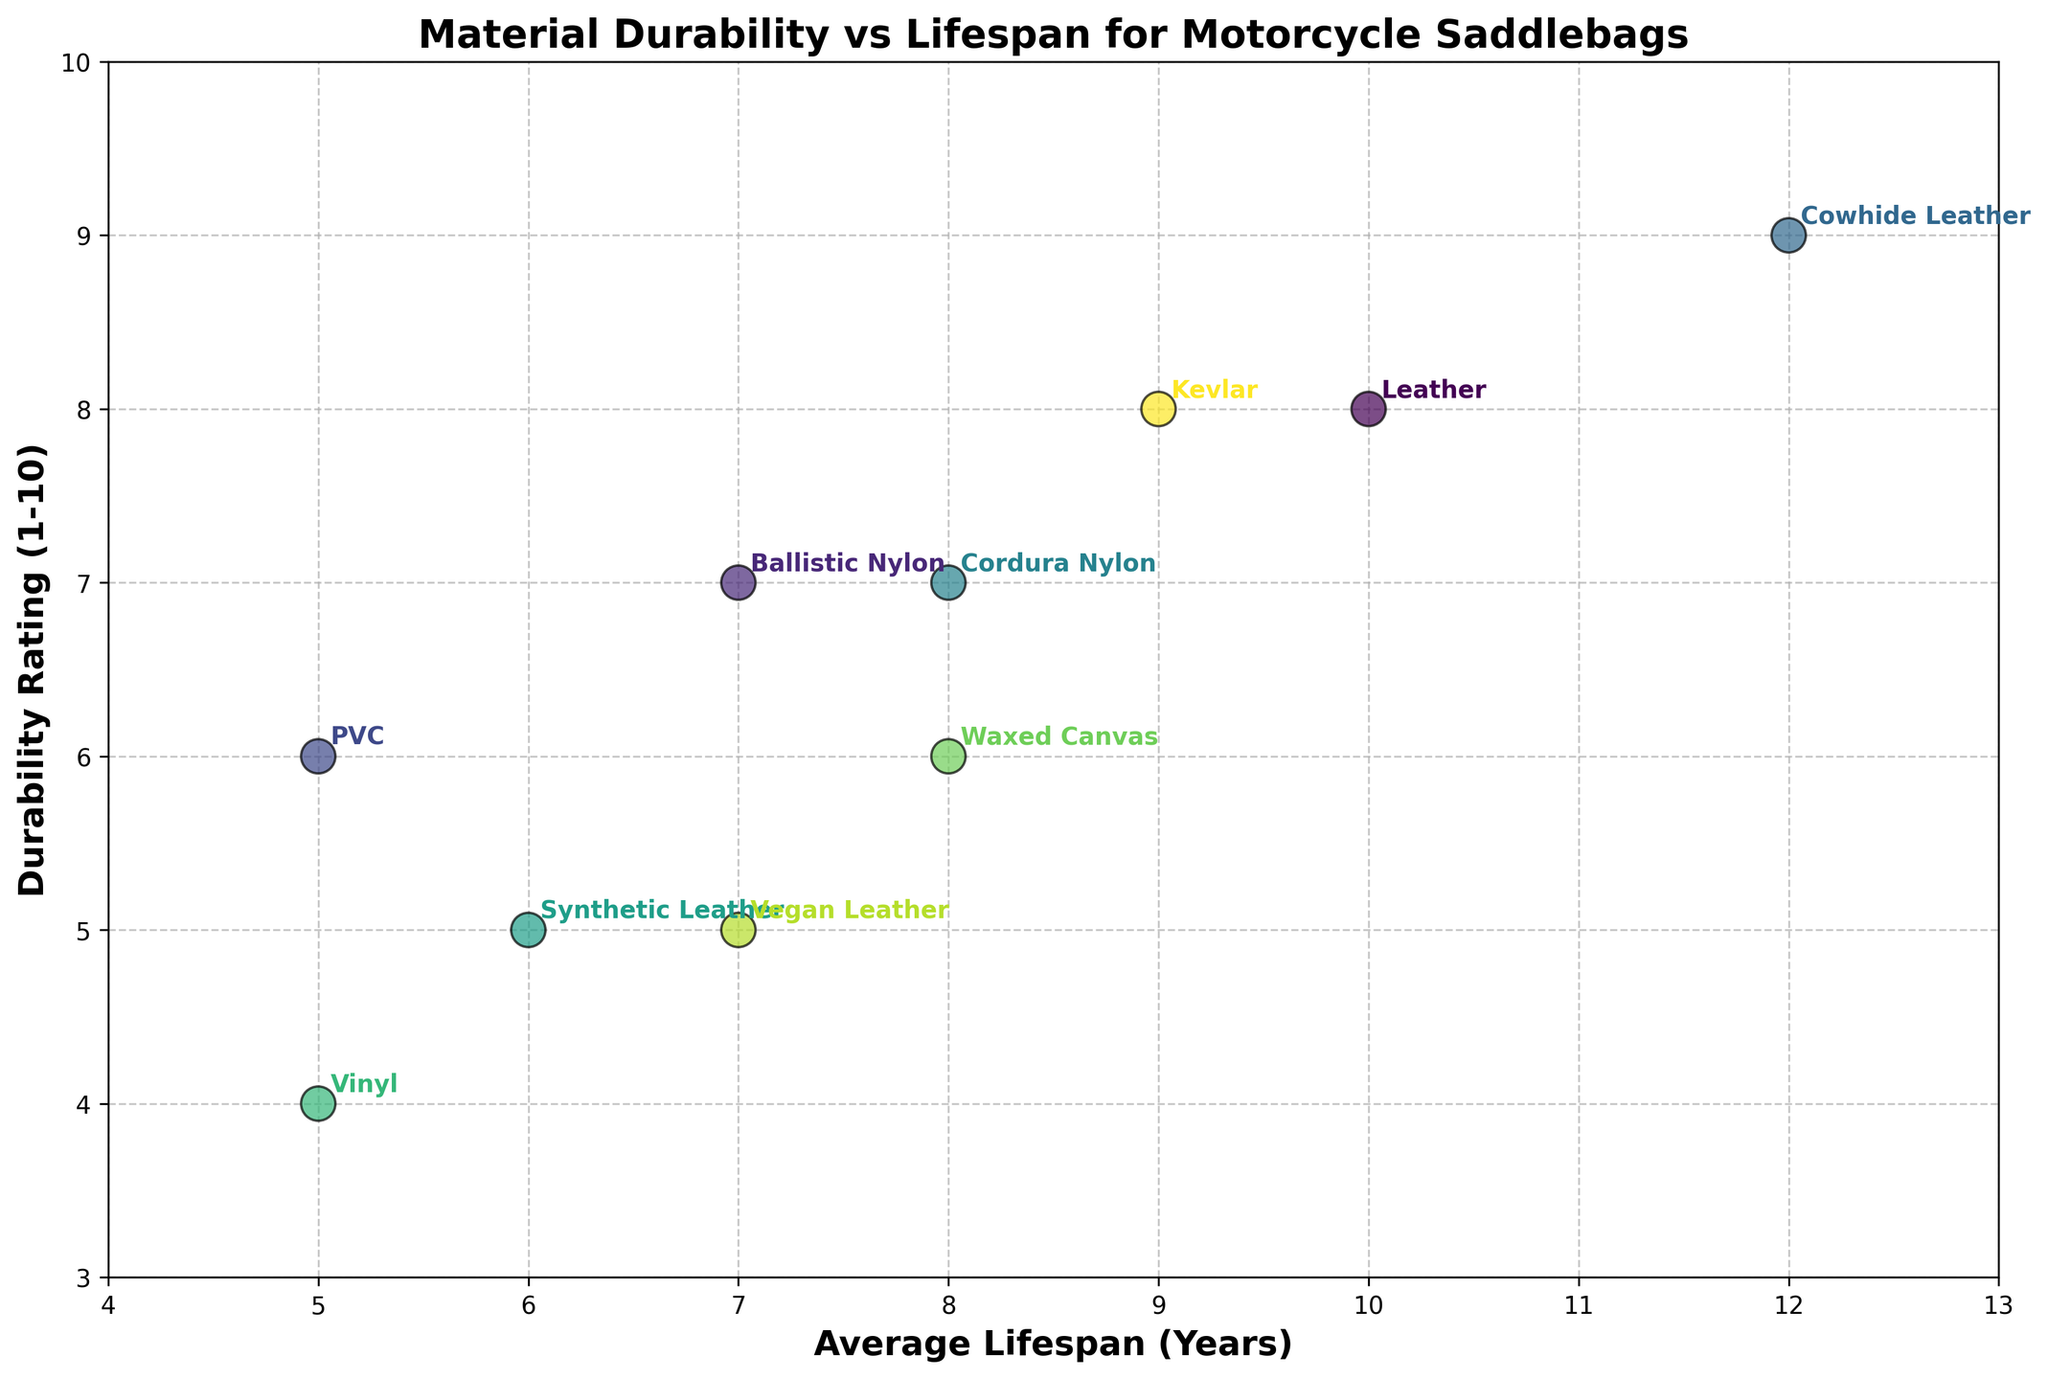What material has the highest durability rating? The highest durability rating is 9, which is shown by Cowhide Leather.
Answer: Cowhide Leather What's the average lifespan of Vinyl? Identify the point labeled 'Vinyl' and check its x-coordinate, representing average lifespan. Vinyl has an average lifespan of 5 years.
Answer: 5 years Which material has both an average lifespan of 9 years and a high durability rating? Locate the point at x=9 on the x-axis and check the corresponding y-value and label. The material is Kevlar.
Answer: Kevlar How many materials have a durability rating of 7? Count the points with a y-coordinate of 7. There are three materials: Ballistic Nylon, Cordura Nylon, and Vegan Leather.
Answer: 3 materials Compare the durability rating of Leather and PVC. Check the y-coordinates for the points labeled 'Leather' and 'PVC.' Leather has a durability rating of 8, while PVC has a rating of 6.
Answer: Leather is more durable Which material has the shortest average lifespan, and what is its durability rating? Check for the point with the lowest x-coordinate. Vinyl has the shortest lifespan of 5 years and a durability rating of 4.
Answer: Vinyl, 4 What is the difference in lifespan between Cowhide Leather and Synthetic Leather? Note their x-coordinates: 12 years for Cowhide Leather and 6 years for Synthetic Leather. The difference is 6 years.
Answer: 6 years Identify the material with the highest durability but less than 10 years lifespan. Look for the point with the highest y-coordinate less than 10 years on the x-axis. The material is Cowhide Leather with a durability rating of 9.
Answer: Cowhide Leather Which material has the same durability rating as Waxed Canvas but a different lifespan? Locate Waxed Canvas, which has a durability rating of 6. Then find another point with the same y-coordinate but a different x-coordinate. PVC also has a durability rating of 6 but a lifespan of 5 years.
Answer: PVC What's the range of average lifespans among all materials? Find the minimum and maximum x-coordinates. Vinyl has the shortest lifespan of 5 years, and Cowhide Leather has the longest lifespan of 12 years. The range is 12 - 5 = 7 years.
Answer: 7 years 